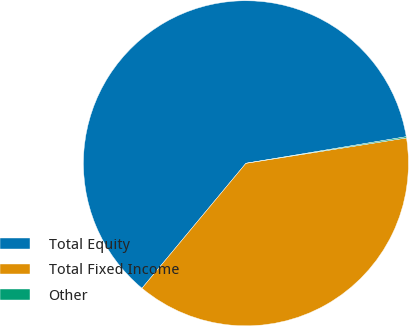Convert chart. <chart><loc_0><loc_0><loc_500><loc_500><pie_chart><fcel>Total Equity<fcel>Total Fixed Income<fcel>Other<nl><fcel>61.35%<fcel>38.54%<fcel>0.12%<nl></chart> 